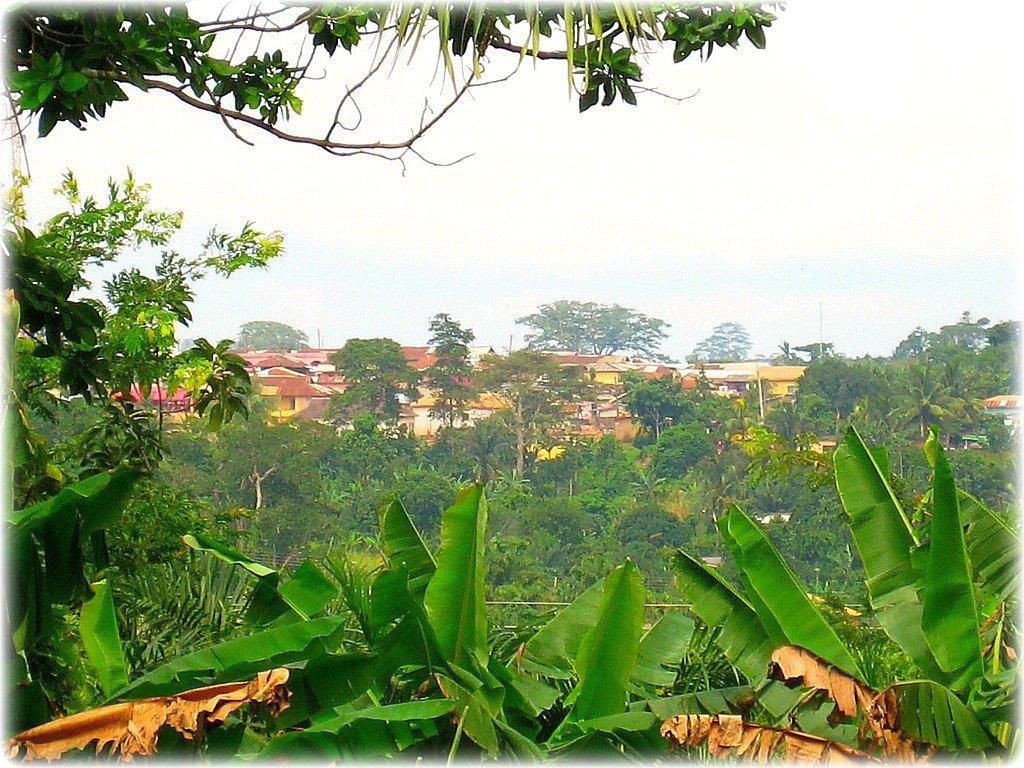What type of vegetation can be seen in the background of the image? There are trees in the background of the image. What type of structures are visible in the background of the image? There are houses in the background of the image. What is visible at the top of the image? The sky is visible at the top of the image. How many pies are on the needle in the image? There are no pies or needles present in the image. What is the temper of the person in the image? There is no person present in the image, so it is not possible to determine their temper. 